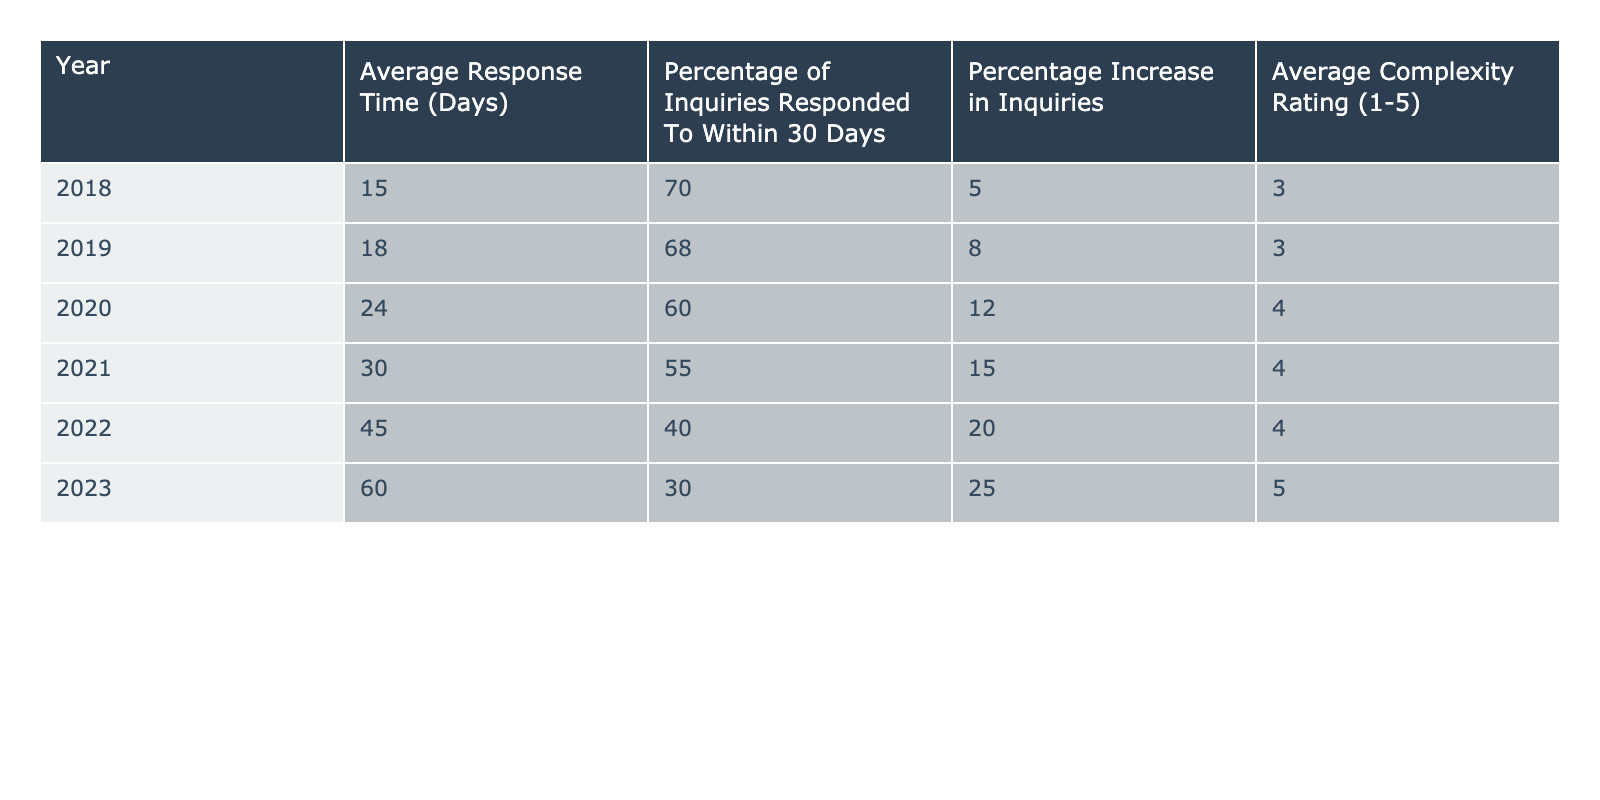What was the average response time for the IRS in 2020? The average response time for the IRS in 2020 is listed in the table under the column "Average Response Time (Days)" for the year 2020, which shows a value of 24 days.
Answer: 24 days What percentage of inquiries were responded to within 30 days in 2021? The table indicates that the percentage of inquiries responded to within 30 days for the year 2021 is 55%, as seen in the relevant column for that year.
Answer: 55% In which year did the IRS experience the greatest average response time? The data shows that the year with the greatest average response time is 2023, with an average response time of 60 days listed under the "Average Response Time (Days)" column.
Answer: 2023 How much did the average response time increase from 2018 to 2023? The average response time in 2018 was 15 days and in 2023 it was 60 days. To find the increase, subtract 15 from 60, which gives 45 days.
Answer: 45 days What is the percentage of inquiries responded to within 30 days in 2018 compared to 2023? In 2018, the percentage was 70%, and in 2023 it decreased to 30%. This shows a decline of 40 percentage points over the five years.
Answer: 40 percentage points True or False: The average complexity rating increased from 2018 to 2023. The complexity rating in 2018 was 3 and in 2023 it is 5. Since 5 is greater than 3, it confirms that the average complexity rating did indeed increase.
Answer: True What was the total increase in the average complexity rating from 2018 to 2023? The complexity rating increased from 3 in 2018 to 5 in 2023. To find the total increase, subtract 3 from 5, resulting in an increase of 2.
Answer: 2 If the trend continues, what might be the average response time in 2024, based on the previous increases? We see the average response time has increased from 15 to 60 days across six years. The increases are respectively 3, 6, 6, 15, and 15 days for the years. If we take the pattern of increase in the last two years as an indicator (15 days), we might estimate an average response time of around 75 days for 2024.
Answer: 75 days How does the percentage increase in inquiries relate to the average response time from 2019 to 2023? The percentage increase in inquiries from 2019 to 2023 can be calculated: from 8% in 2019 to 25% in 2023, showing a total increase of 17 percentage points. However, during this time, the average response time increased from 18 days to 60 days, which is an increase of 42 days. This illustrates that despite the increase in inquiries, the response time worsened significantly during these years.
Answer: 17 percentage points increase in inquiries, 42 days increase in response time 